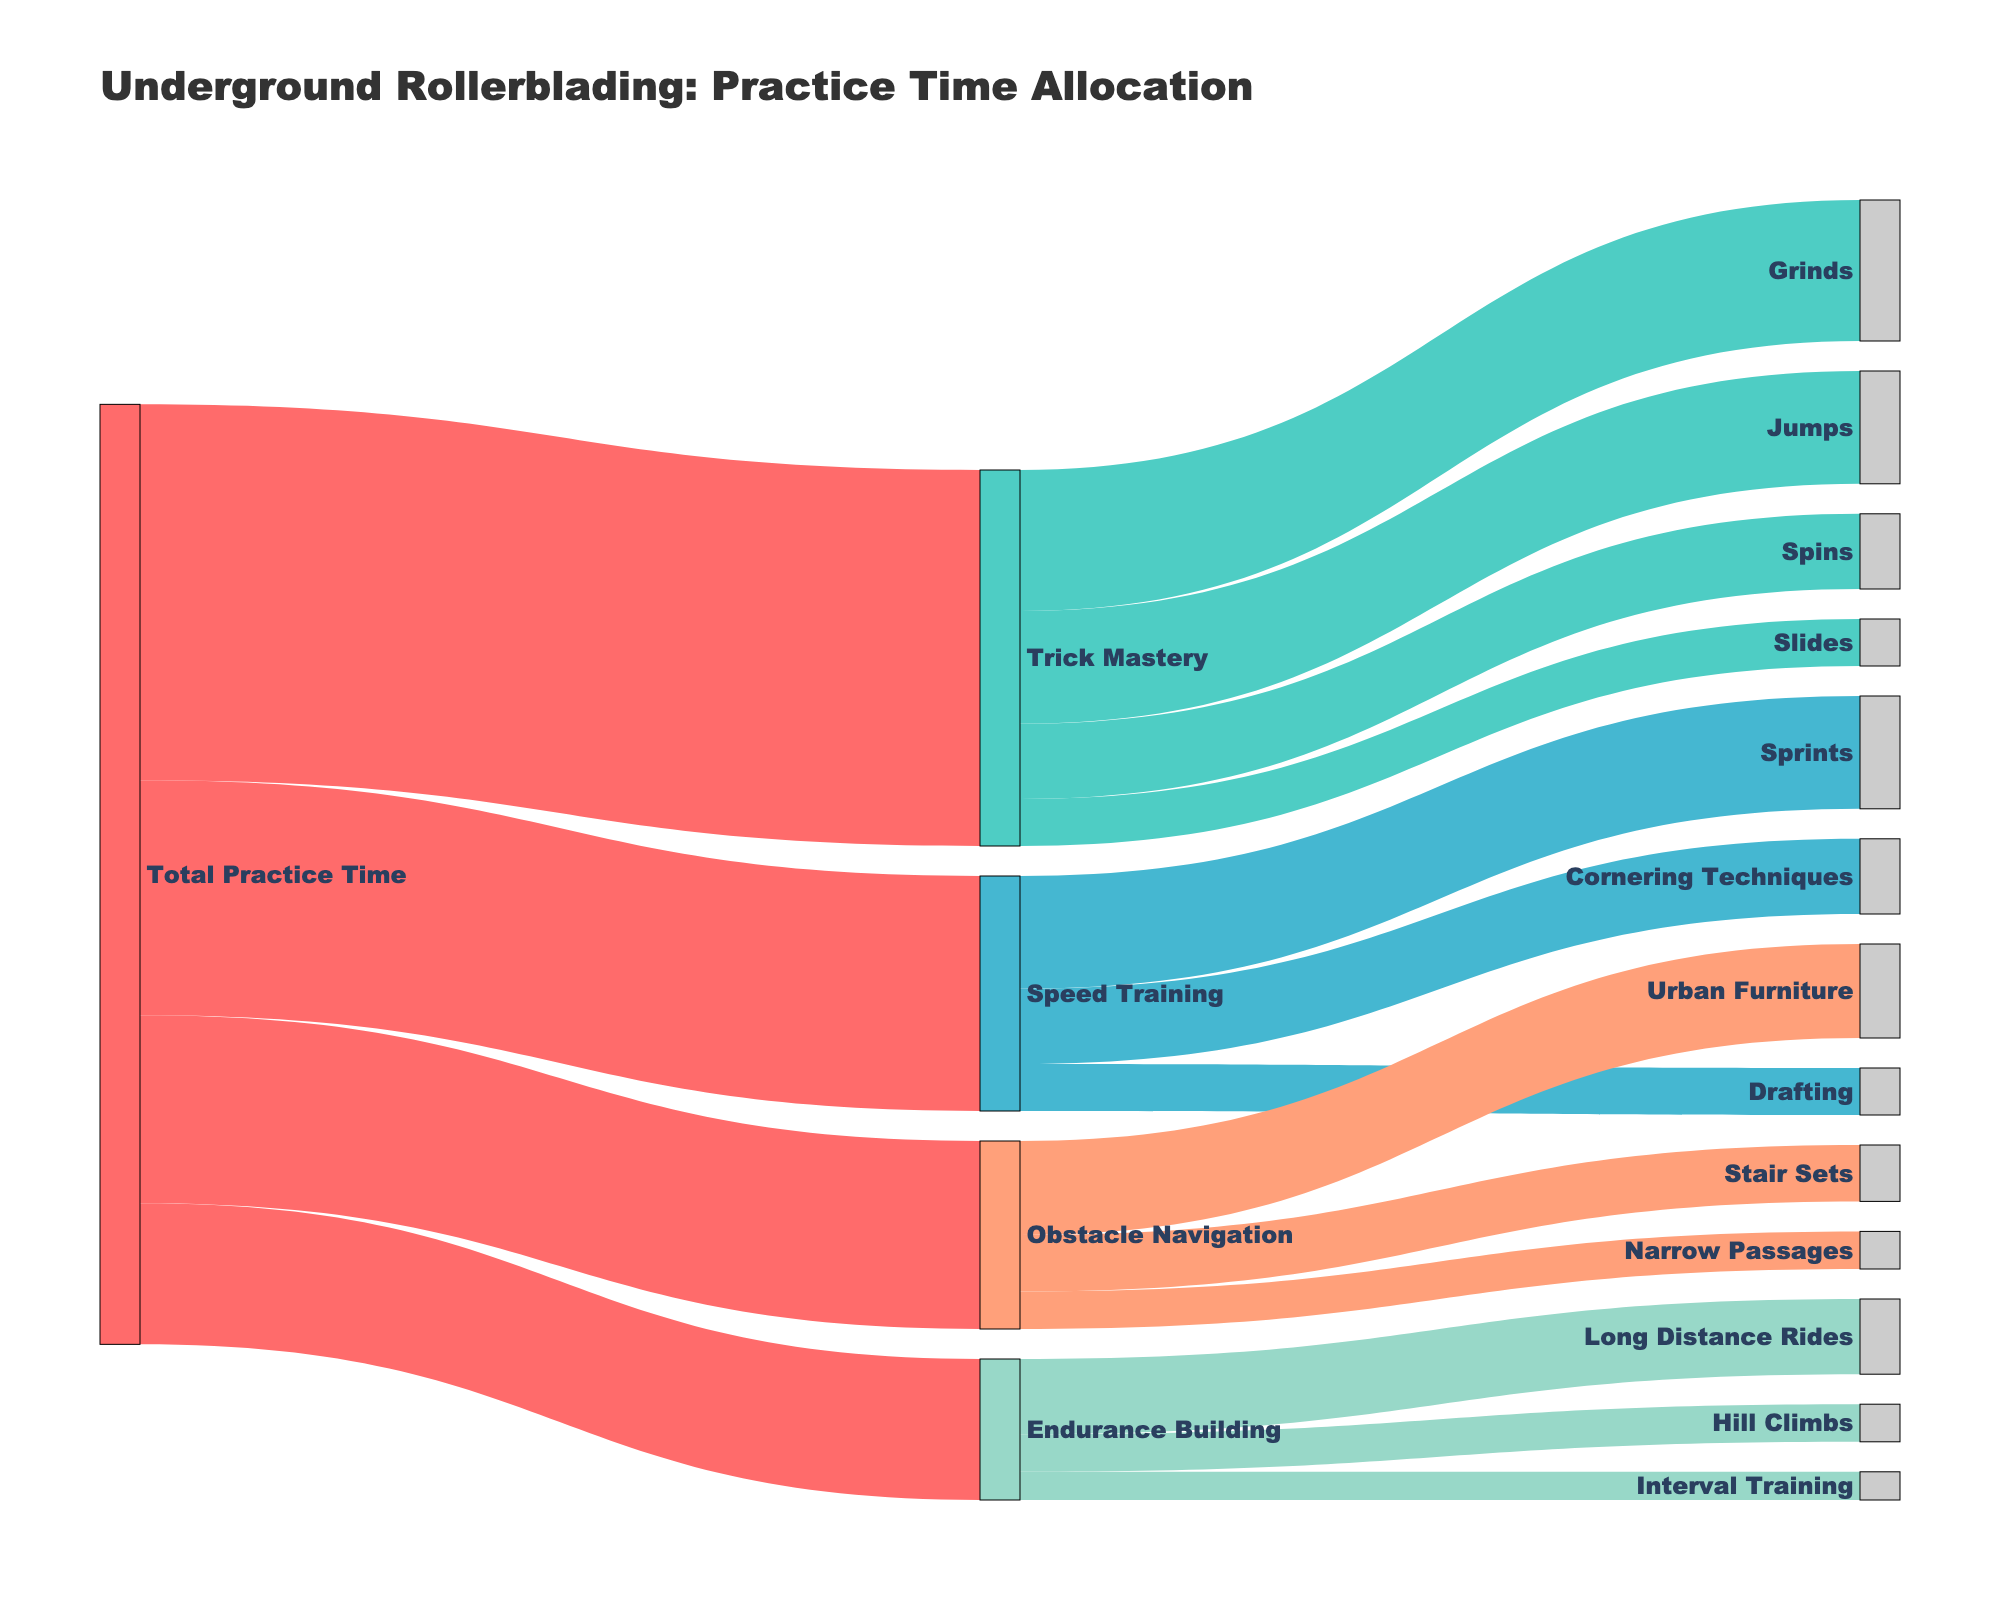What's the title of the Sankey diagram? The title of the Sankey diagram is displayed at the top of the figure, and it summarizes the main topic or focus of the visualization.
Answer: Underground Rollerblading: Practice Time Allocation What percentage of the total practice time is allocated to Trick Mastery? The Total Practice Time is 100%. Trick Mastery accounts for 40 out of the 100 units of practice time. Thus, the percentage is calculated as (40/100) * 100%.
Answer: 40% Which skill development area has the least allocation of practice time? By comparing the values allocated to each skill development area (Trick Mastery: 40, Speed Training: 25, Obstacle Navigation: 20, Endurance Building: 15), the smallest value is 15 for Endurance Building.
Answer: Endurance Building Among the subcategories of Trick Mastery, which one receives the most practice time, and how much is it? By looking at the breakdown of Trick Mastery into Grinds, Jumps, Spins, and Slides, Grinds has the highest allocation with 15 units.
Answer: Grinds, 15 units How much is the combined practice time allocated to Grinds and Long Distance Rides? The time allocated to Grinds is 15 units and to Long Distance Rides is 8 units. Summing these gives 15 + 8 = 23 units.
Answer: 23 units What is the combined practice time for all the subcategories under Endurance Building? The subcategories under Endurance Building are Long Distance Rides (8), Hill Climbs (4), and Interval Training (3). Adding these gives 8 + 4 + 3 = 15 units.
Answer: 15 units Which area of practice takes more time: Speed Training or Obstacle Navigation? Speed Training has 25 units of practice time, while Obstacle Navigation has 20 units. Therefore, Speed Training takes more time.
Answer: Speed Training What is the ratio of time spent on Speed Training to Trick Mastery? Speed Training has 25 units, and Trick Mastery has 40 units. The ratio is calculated as 25/40, which simplifies to 5/8.
Answer: 5:8 Postulate why there might be a higher allocation of practice time for Trick Mastery compared to Endurance Building? Possible reasons could include the complexity and various technical skills involved in Trick Mastery that require more dedicated practice time to master different tricks like Grinds, Jumps, Spins, and Slides.
Answer: Trick Mastery involves complex skills 